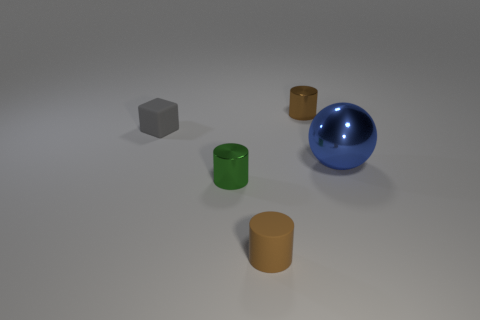Add 3 brown metallic cylinders. How many objects exist? 8 Subtract all shiny cylinders. How many cylinders are left? 1 Subtract all cylinders. How many objects are left? 2 Subtract 1 cylinders. How many cylinders are left? 2 Subtract all small brown cylinders. Subtract all big blue metallic spheres. How many objects are left? 2 Add 3 green things. How many green things are left? 4 Add 4 green cylinders. How many green cylinders exist? 5 Subtract all brown cylinders. How many cylinders are left? 1 Subtract 1 green cylinders. How many objects are left? 4 Subtract all purple spheres. Subtract all gray cylinders. How many spheres are left? 1 